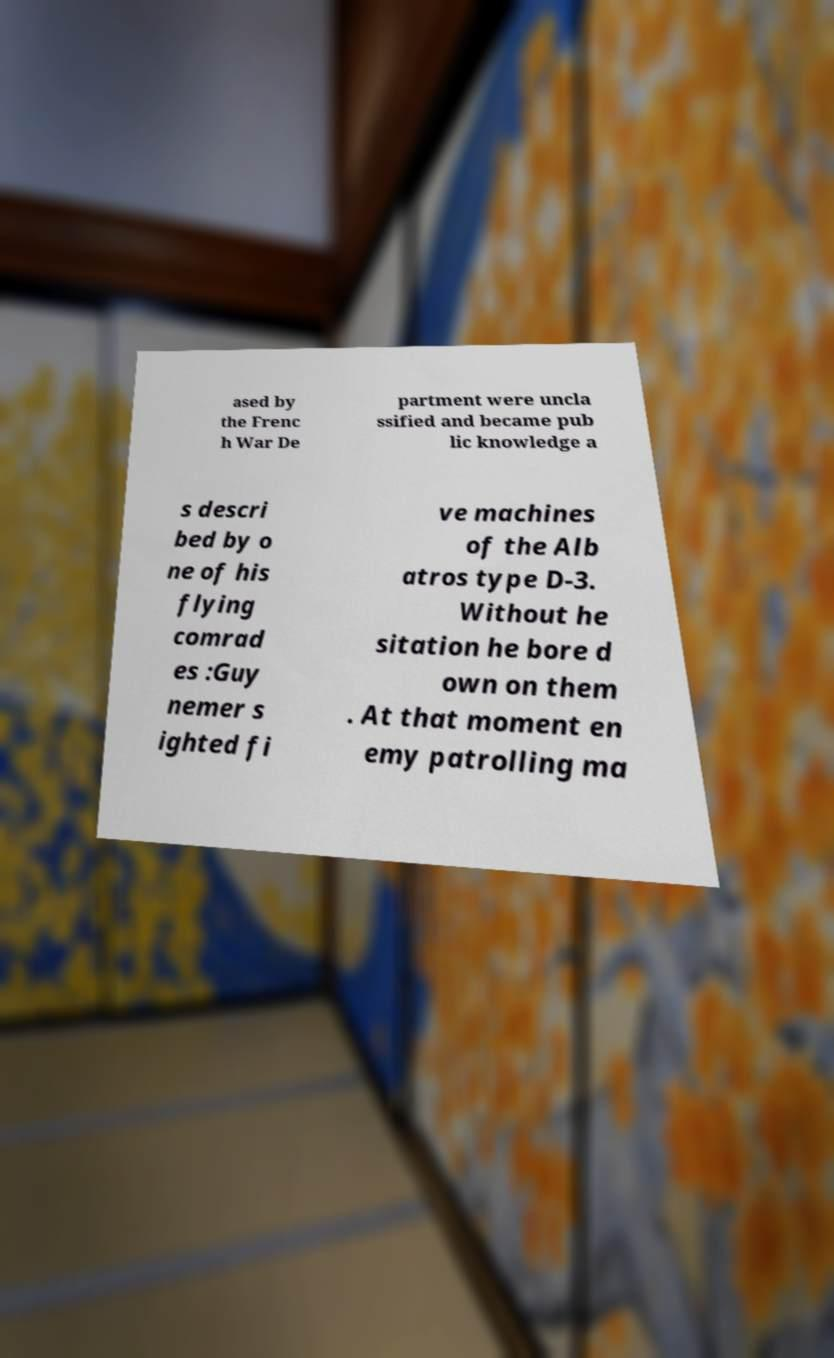Please identify and transcribe the text found in this image. ased by the Frenc h War De partment were uncla ssified and became pub lic knowledge a s descri bed by o ne of his flying comrad es :Guy nemer s ighted fi ve machines of the Alb atros type D-3. Without he sitation he bore d own on them . At that moment en emy patrolling ma 